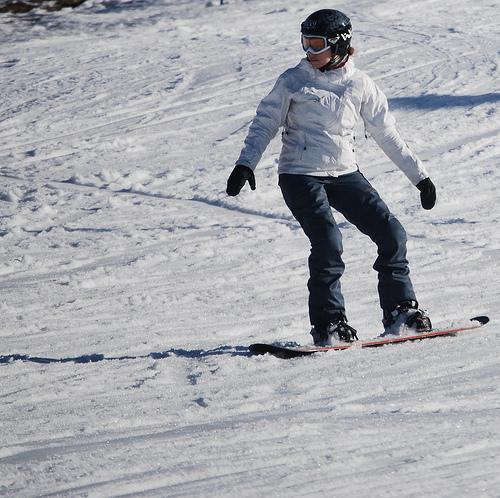How many snowboarders are in this picture?
Give a very brief answer. 1. How many trees are this picture?
Give a very brief answer. 0. 